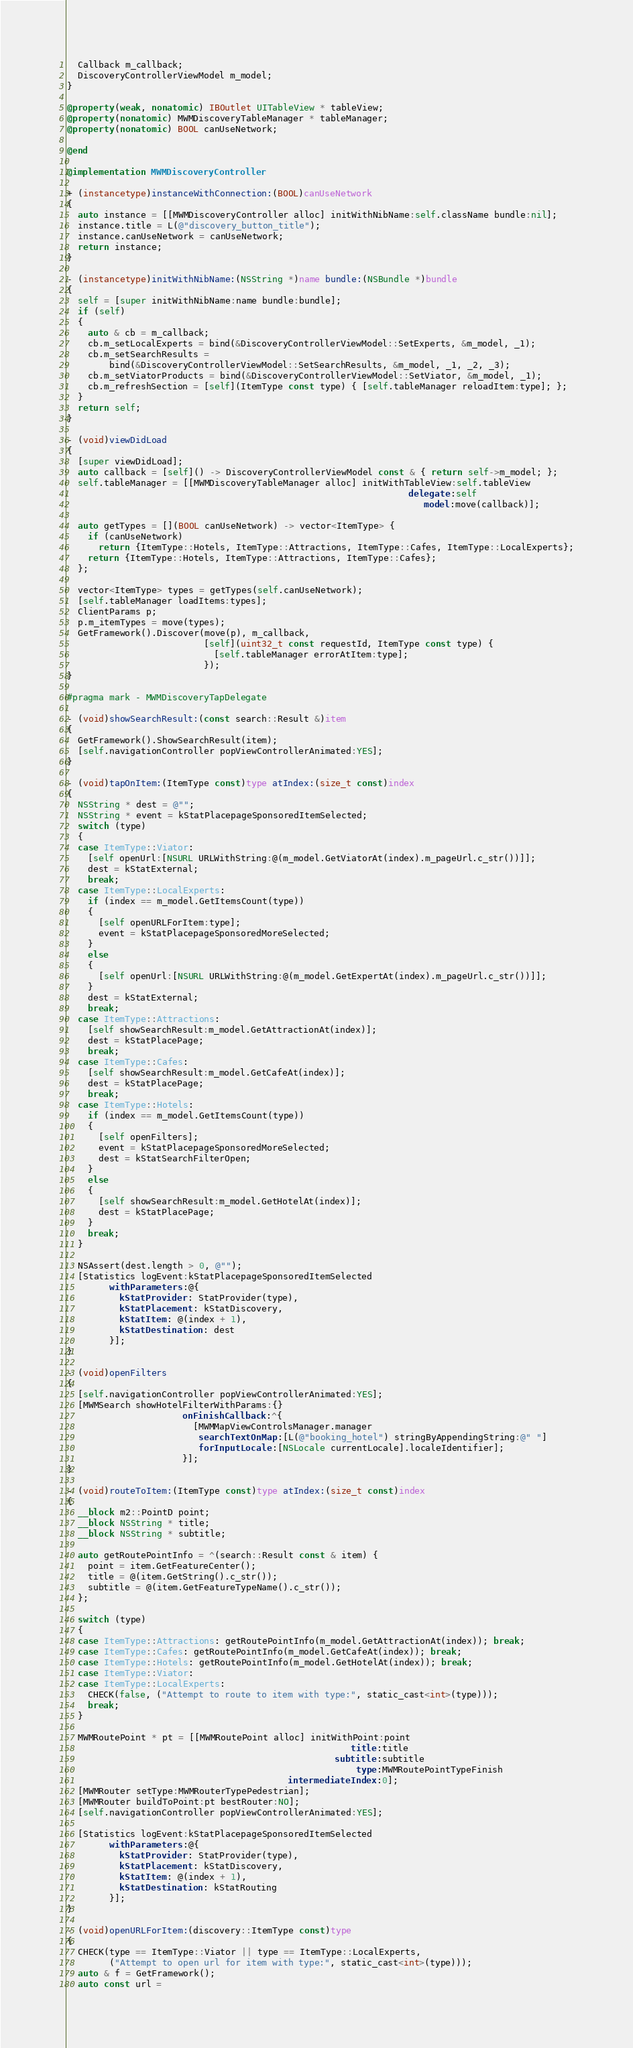<code> <loc_0><loc_0><loc_500><loc_500><_ObjectiveC_>  Callback m_callback;
  DiscoveryControllerViewModel m_model;
}

@property(weak, nonatomic) IBOutlet UITableView * tableView;
@property(nonatomic) MWMDiscoveryTableManager * tableManager;
@property(nonatomic) BOOL canUseNetwork;

@end

@implementation MWMDiscoveryController

+ (instancetype)instanceWithConnection:(BOOL)canUseNetwork
{
  auto instance = [[MWMDiscoveryController alloc] initWithNibName:self.className bundle:nil];
  instance.title = L(@"discovery_button_title");
  instance.canUseNetwork = canUseNetwork;
  return instance;
}

- (instancetype)initWithNibName:(NSString *)name bundle:(NSBundle *)bundle
{
  self = [super initWithNibName:name bundle:bundle];
  if (self)
  {
    auto & cb = m_callback;
    cb.m_setLocalExperts = bind(&DiscoveryControllerViewModel::SetExperts, &m_model, _1);
    cb.m_setSearchResults =
        bind(&DiscoveryControllerViewModel::SetSearchResults, &m_model, _1, _2, _3);
    cb.m_setViatorProducts = bind(&DiscoveryControllerViewModel::SetViator, &m_model, _1);
    cb.m_refreshSection = [self](ItemType const type) { [self.tableManager reloadItem:type]; };
  }
  return self;
}

- (void)viewDidLoad
{
  [super viewDidLoad];
  auto callback = [self]() -> DiscoveryControllerViewModel const & { return self->m_model; };
  self.tableManager = [[MWMDiscoveryTableManager alloc] initWithTableView:self.tableView
                                                                 delegate:self
                                                                    model:move(callback)];

  auto getTypes = [](BOOL canUseNetwork) -> vector<ItemType> {
    if (canUseNetwork)
      return {ItemType::Hotels, ItemType::Attractions, ItemType::Cafes, ItemType::LocalExperts};
    return {ItemType::Hotels, ItemType::Attractions, ItemType::Cafes};
  };

  vector<ItemType> types = getTypes(self.canUseNetwork);
  [self.tableManager loadItems:types];
  ClientParams p;
  p.m_itemTypes = move(types);
  GetFramework().Discover(move(p), m_callback,
                          [self](uint32_t const requestId, ItemType const type) {
                            [self.tableManager errorAtItem:type];
                          });
}

#pragma mark - MWMDiscoveryTapDelegate

- (void)showSearchResult:(const search::Result &)item
{
  GetFramework().ShowSearchResult(item);
  [self.navigationController popViewControllerAnimated:YES];
}

- (void)tapOnItem:(ItemType const)type atIndex:(size_t const)index
{
  NSString * dest = @"";
  NSString * event = kStatPlacepageSponsoredItemSelected;
  switch (type)
  {
  case ItemType::Viator:
    [self openUrl:[NSURL URLWithString:@(m_model.GetViatorAt(index).m_pageUrl.c_str())]];
    dest = kStatExternal;
    break;
  case ItemType::LocalExperts:
    if (index == m_model.GetItemsCount(type))
    {
      [self openURLForItem:type];
      event = kStatPlacepageSponsoredMoreSelected;
    }
    else
    {
      [self openUrl:[NSURL URLWithString:@(m_model.GetExpertAt(index).m_pageUrl.c_str())]];
    }
    dest = kStatExternal;
    break;
  case ItemType::Attractions:
    [self showSearchResult:m_model.GetAttractionAt(index)];
    dest = kStatPlacePage;
    break;
  case ItemType::Cafes:
    [self showSearchResult:m_model.GetCafeAt(index)];
    dest = kStatPlacePage;
    break;
  case ItemType::Hotels:
    if (index == m_model.GetItemsCount(type))
    {
      [self openFilters];
      event = kStatPlacepageSponsoredMoreSelected;
      dest = kStatSearchFilterOpen;
    }
    else
    {
      [self showSearchResult:m_model.GetHotelAt(index)];
      dest = kStatPlacePage;
    }
    break;
  }

  NSAssert(dest.length > 0, @"");
  [Statistics logEvent:kStatPlacepageSponsoredItemSelected
        withParameters:@{
          kStatProvider: StatProvider(type),
          kStatPlacement: kStatDiscovery,
          kStatItem: @(index + 1),
          kStatDestination: dest
        }];
}

- (void)openFilters
{
  [self.navigationController popViewControllerAnimated:YES];
  [MWMSearch showHotelFilterWithParams:{}
                      onFinishCallback:^{
                        [MWMMapViewControlsManager.manager
                         searchTextOnMap:[L(@"booking_hotel") stringByAppendingString:@" "]
                         forInputLocale:[NSLocale currentLocale].localeIdentifier];
                      }];
}

- (void)routeToItem:(ItemType const)type atIndex:(size_t const)index
{
  __block m2::PointD point;
  __block NSString * title;
  __block NSString * subtitle;

  auto getRoutePointInfo = ^(search::Result const & item) {
    point = item.GetFeatureCenter();
    title = @(item.GetString().c_str());
    subtitle = @(item.GetFeatureTypeName().c_str());
  };

  switch (type)
  {
  case ItemType::Attractions: getRoutePointInfo(m_model.GetAttractionAt(index)); break;
  case ItemType::Cafes: getRoutePointInfo(m_model.GetCafeAt(index)); break;
  case ItemType::Hotels: getRoutePointInfo(m_model.GetHotelAt(index)); break;
  case ItemType::Viator:
  case ItemType::LocalExperts:
    CHECK(false, ("Attempt to route to item with type:", static_cast<int>(type)));
    break;
  }

  MWMRoutePoint * pt = [[MWMRoutePoint alloc] initWithPoint:point
                                                      title:title
                                                   subtitle:subtitle
                                                       type:MWMRoutePointTypeFinish
                                          intermediateIndex:0];
  [MWMRouter setType:MWMRouterTypePedestrian];
  [MWMRouter buildToPoint:pt bestRouter:NO];
  [self.navigationController popViewControllerAnimated:YES];

  [Statistics logEvent:kStatPlacepageSponsoredItemSelected
        withParameters:@{
          kStatProvider: StatProvider(type),
          kStatPlacement: kStatDiscovery,
          kStatItem: @(index + 1),
          kStatDestination: kStatRouting
        }];
}

- (void)openURLForItem:(discovery::ItemType const)type
{
  CHECK(type == ItemType::Viator || type == ItemType::LocalExperts,
        ("Attempt to open url for item with type:", static_cast<int>(type)));
  auto & f = GetFramework();
  auto const url =</code> 